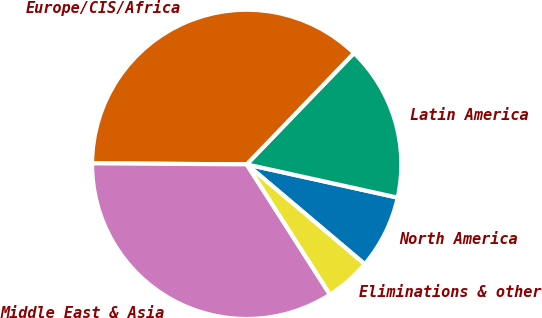<chart> <loc_0><loc_0><loc_500><loc_500><pie_chart><fcel>North America<fcel>Latin America<fcel>Europe/CIS/Africa<fcel>Middle East & Asia<fcel>Eliminations & other<nl><fcel>7.72%<fcel>16.24%<fcel>37.1%<fcel>34.16%<fcel>4.77%<nl></chart> 